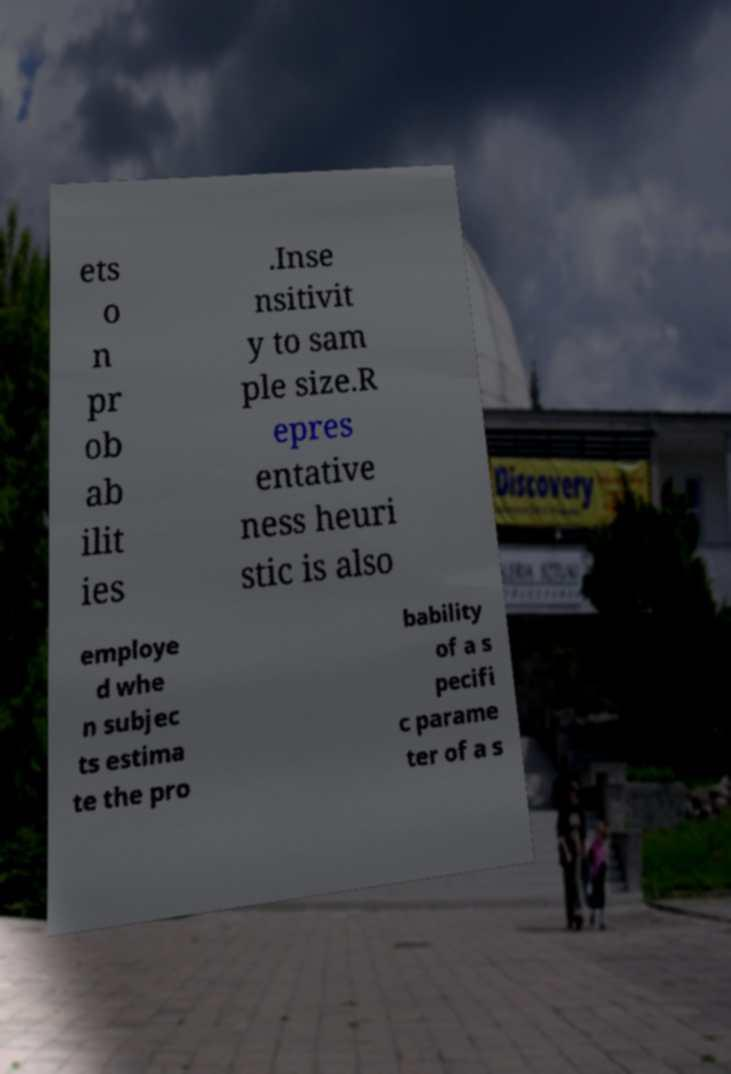Please read and relay the text visible in this image. What does it say? ets o n pr ob ab ilit ies .Inse nsitivit y to sam ple size.R epres entative ness heuri stic is also employe d whe n subjec ts estima te the pro bability of a s pecifi c parame ter of a s 